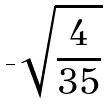<formula> <loc_0><loc_0><loc_500><loc_500>- \sqrt { \frac { 4 } { 3 5 } }</formula> 